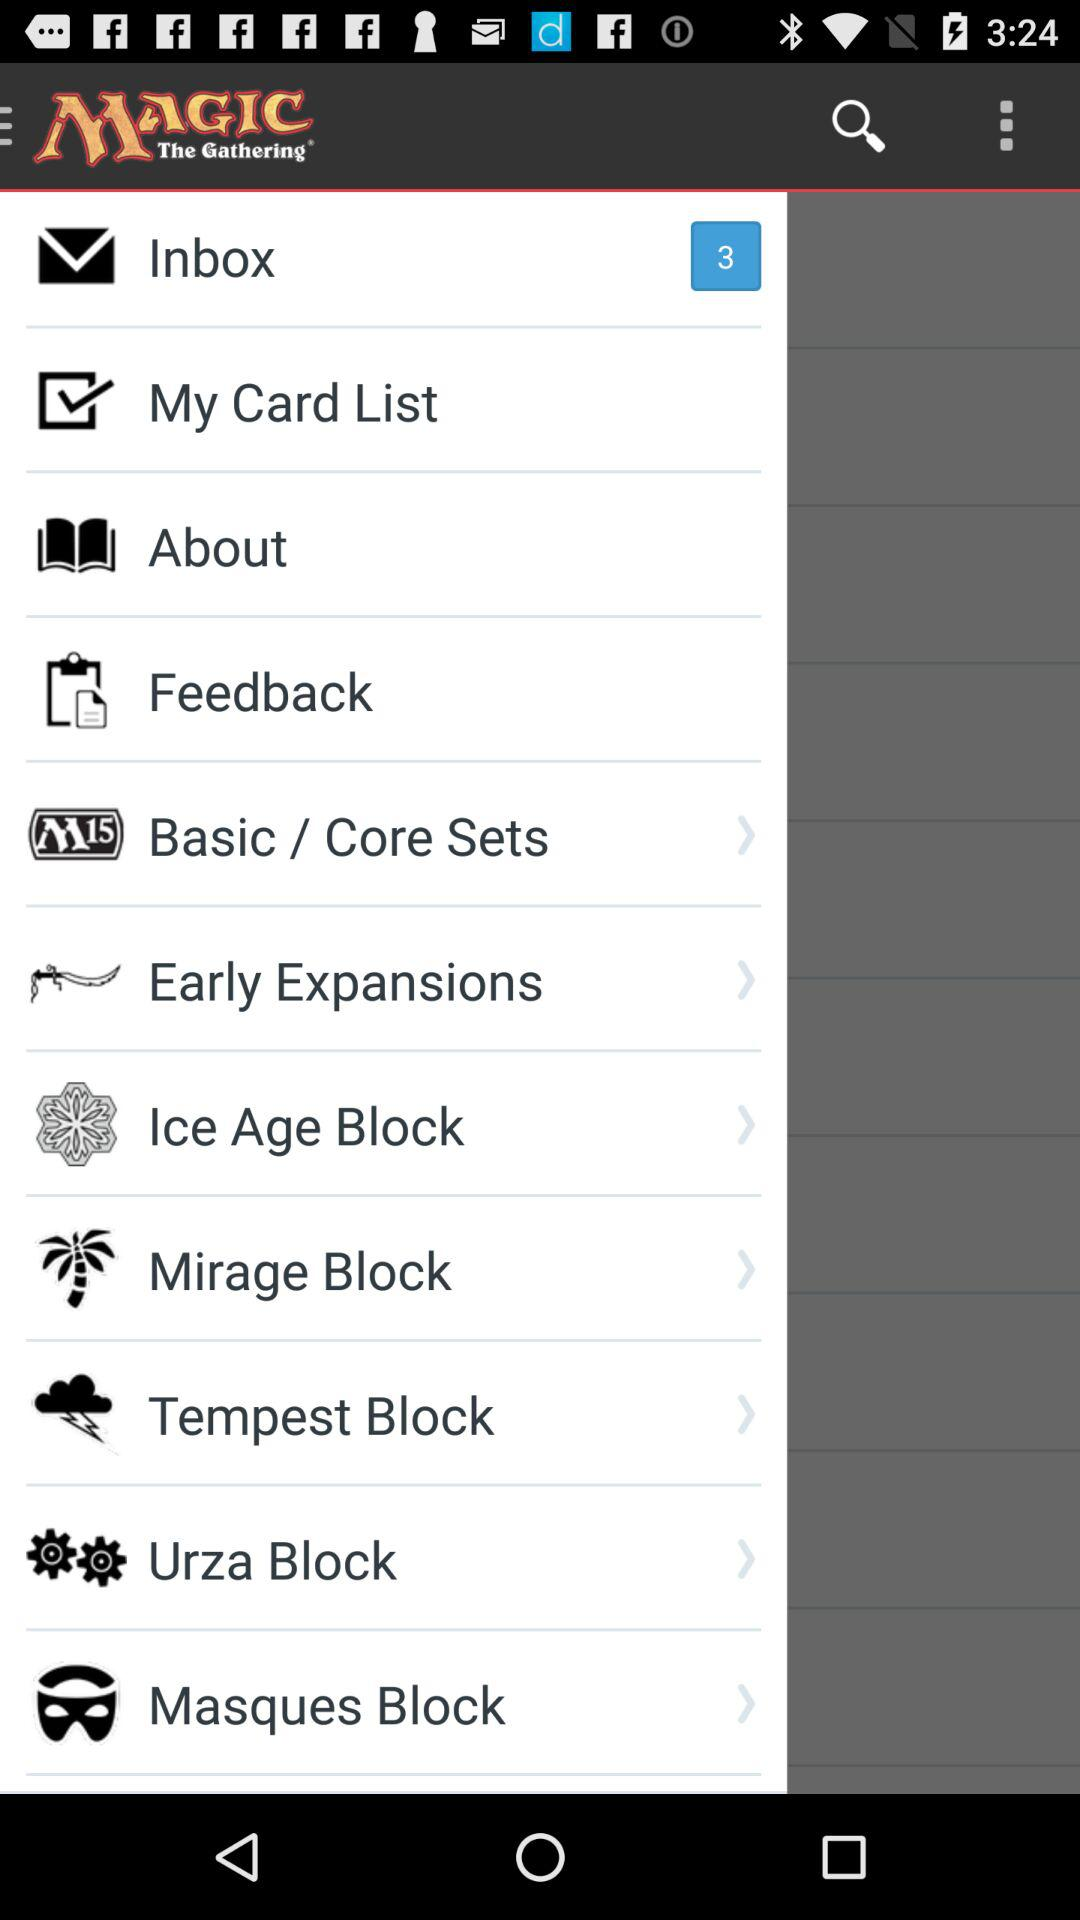What is the name of the application? The application name is "MAGIC The Gathering". 